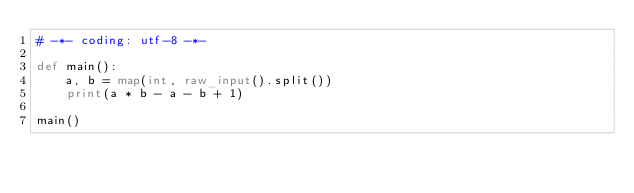<code> <loc_0><loc_0><loc_500><loc_500><_Python_># -*- coding: utf-8 -*-

def main():
    a, b = map(int, raw_input().split())
    print(a * b - a - b + 1)

main()
</code> 